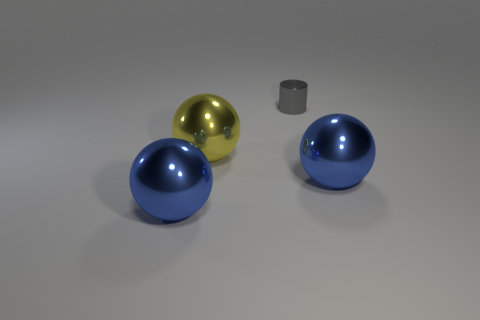There is a small gray object; what number of blue metal objects are to the left of it?
Your answer should be very brief. 1. What material is the blue thing to the right of the blue metallic sphere that is on the left side of the small gray metal cylinder made of?
Keep it short and to the point. Metal. Is there anything else that has the same size as the yellow object?
Your response must be concise. Yes. Do the gray thing and the yellow thing have the same size?
Offer a terse response. No. What number of things are blue balls right of the gray cylinder or large spheres right of the yellow metallic sphere?
Keep it short and to the point. 1. Are there more blue metal things in front of the yellow shiny thing than yellow spheres?
Your answer should be very brief. Yes. What number of other objects are there of the same shape as the gray object?
Your answer should be very brief. 0. There is a sphere that is both in front of the large yellow ball and to the left of the tiny gray metal object; what material is it?
Offer a terse response. Metal. How many objects are either big purple rubber objects or big blue shiny spheres?
Your answer should be compact. 2. Are there more metal cylinders than metal things?
Make the answer very short. No. 